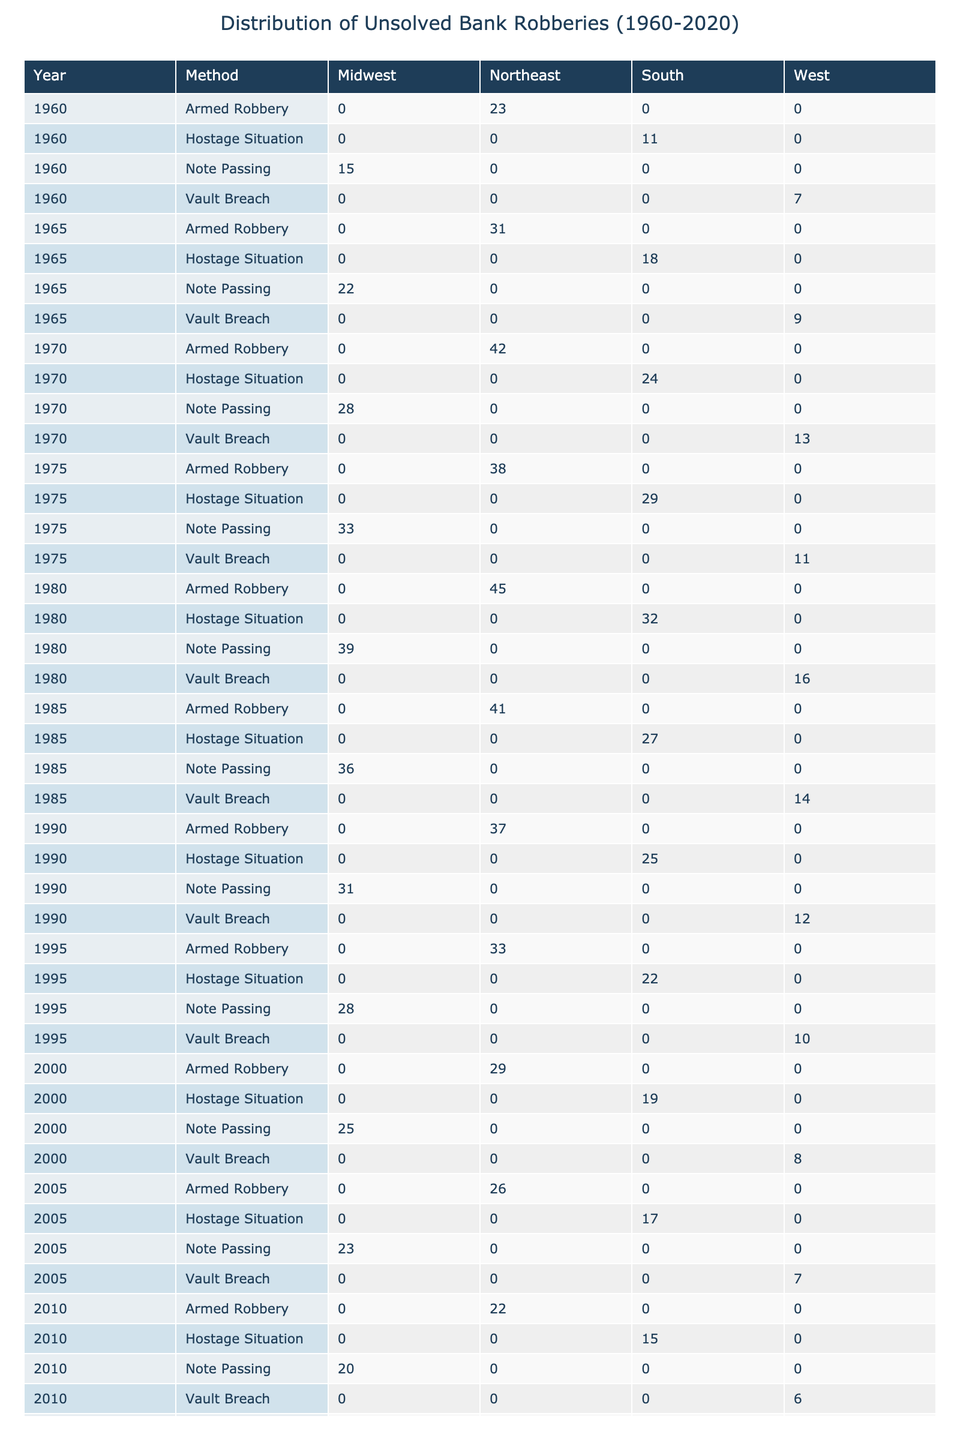What's the highest number of armed robbery cases recorded in the Northeast? In the table, the armed robbery cases for the Northeast across different years are 23, 31, 42, 38, 45, 41, 37, 33, 29, 26, 22, 19, and 17. The highest value among these numbers is 45, which occurred in 1980.
Answer: 45 In which year did the Midwest record the lowest number of note passing cases? The note passing cases for the Midwest across the years are 15, 22, 28, 33, 39, 36, 31, 28, 25, 23, 20, 18, and 16. The lowest value in this list is 15, which occurred in 1960.
Answer: 1960 What is the total number of hostage situations reported in the South between 1960 and 2020? Adding the number of hostage situations in the South gives us 11 + 18 + 24 + 29 + 32 + 27 + 25 + 22 + 19 + 17 + 15 + 13 + 11. This leads to a total of 11 + 18 + 24 + 29 + 32 + 27 + 25 + 22 + 19 + 17 + 15 + 13 + 11 =  359.
Answer: 359 Which method of robbery has consistently maintained a higher number of cases in the Northeast from 1960 to 2020, armed robbery or note passing? By looking at the table, we see the following values for armed robbery in the Northeast: 23, 31, 42, 38, 45, 41, 37, 33, 29, 26, 22, 19, 17. The note passing cases are: 15, 22, 28, 33, 39, 36, 31, 28, 25, 23, 20, 18, 16. Comparing the highest values from both series at any year, armed robbery consistently has more cases, especially with the maximum value of 45 versus the maximum note passing value of 39.
Answer: Armed robbery Is there any recorded instance of vault breach cases in the South? A glance at the table reveals that vault breaches are listed only in the West region for the years specified. This indicates that there are no instances recorded in the South.
Answer: No What is the change in the number of armed robbery cases in the Northeast from 1980 to 2020? The number of armed robbery cases in the Northeast in 1980 was 45 and in 2020 it was 17. The change is calculated as 17 - 45 = -28, indicating a decrease in armed robbery cases over the years.
Answer: -28 Which region had the highest total number of vault breaches from 1960 to 2020? By scrutinizing the vault breach cases from the table: 7 + 9 + 13 + 11 + 16 + 14 + 12 + 10 + 8 + 7 + 6 + 5 + 4. The cumulative total is 7 + 9 + 13 + 11 + 16 + 14 + 12 + 10 + 8 + 7 + 6 + 5 + 4 =  12. Since vault breaches are only recorded in the West, it can be concluded that the West had the highest number of vault breaches totaling 12.
Answer: West 